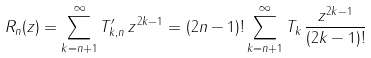<formula> <loc_0><loc_0><loc_500><loc_500>R _ { n } ( z ) = \sum _ { k = n + 1 } ^ { \infty } T ^ { \prime } _ { k , n } \, z ^ { 2 k - 1 } = ( 2 n - 1 ) ! \sum _ { k = n + 1 } ^ { \infty } T _ { k } \, \frac { z ^ { 2 k - 1 } } { ( 2 k - 1 ) ! }</formula> 